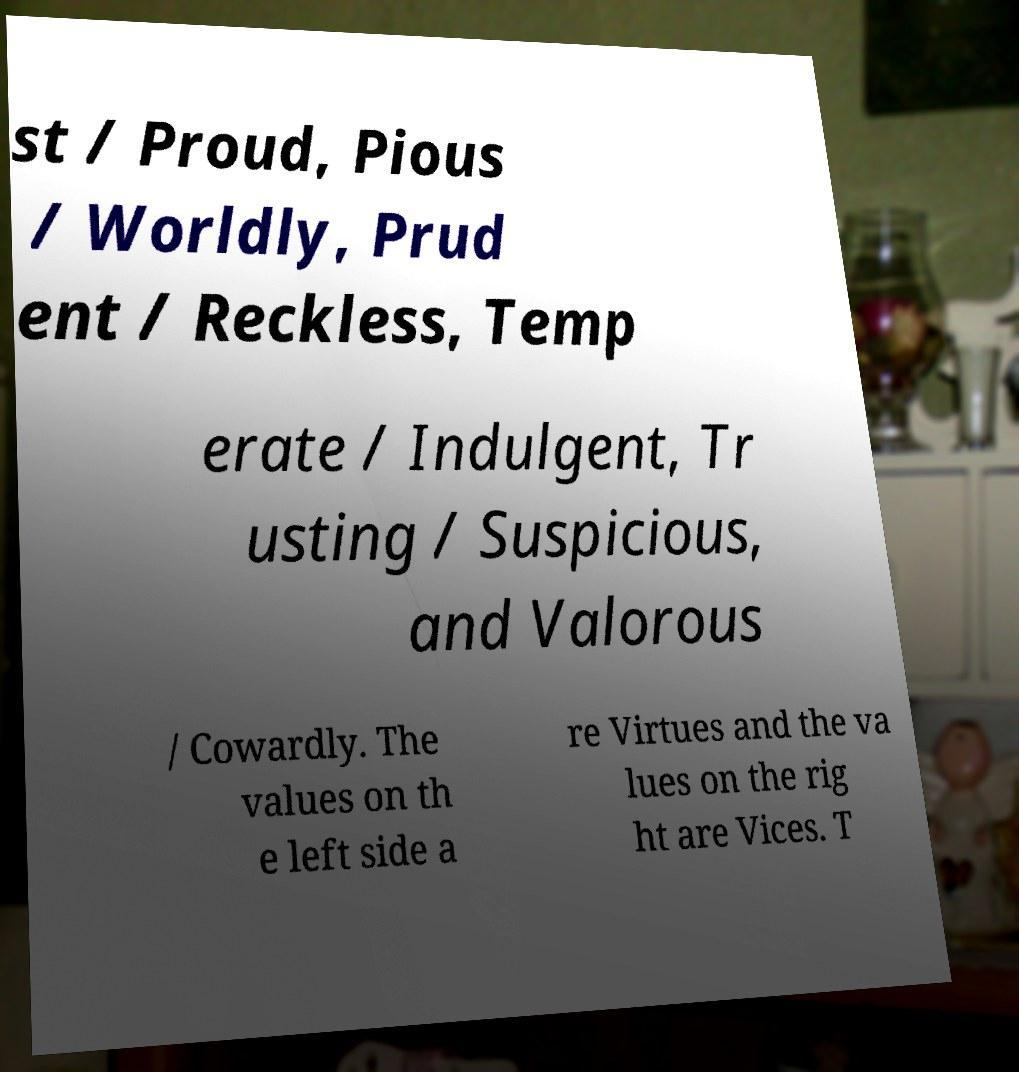Could you assist in decoding the text presented in this image and type it out clearly? st / Proud, Pious / Worldly, Prud ent / Reckless, Temp erate / Indulgent, Tr usting / Suspicious, and Valorous / Cowardly. The values on th e left side a re Virtues and the va lues on the rig ht are Vices. T 